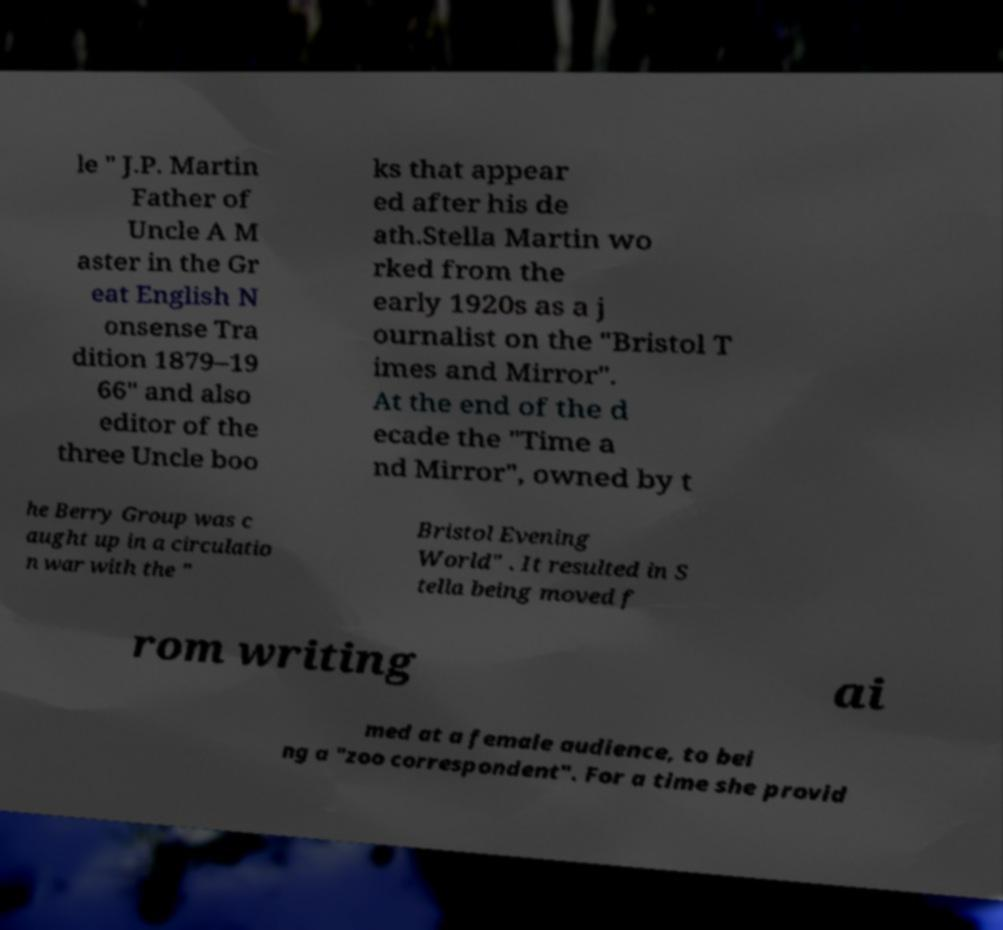Can you read and provide the text displayed in the image?This photo seems to have some interesting text. Can you extract and type it out for me? le " J.P. Martin Father of Uncle A M aster in the Gr eat English N onsense Tra dition 1879–19 66" and also editor of the three Uncle boo ks that appear ed after his de ath.Stella Martin wo rked from the early 1920s as a j ournalist on the "Bristol T imes and Mirror". At the end of the d ecade the "Time a nd Mirror", owned by t he Berry Group was c aught up in a circulatio n war with the " Bristol Evening World" . It resulted in S tella being moved f rom writing ai med at a female audience, to bei ng a "zoo correspondent". For a time she provid 